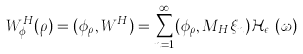Convert formula to latex. <formula><loc_0><loc_0><loc_500><loc_500>W ^ { H } _ { \phi } ( \rho ) = ( \phi _ { \rho } , W ^ { H } ) = \sum ^ { \infty } _ { n = 1 } ( \phi _ { \rho } , M _ { H } \xi _ { n } ) \mathcal { H } _ { \epsilon _ { n } } ( \omega )</formula> 